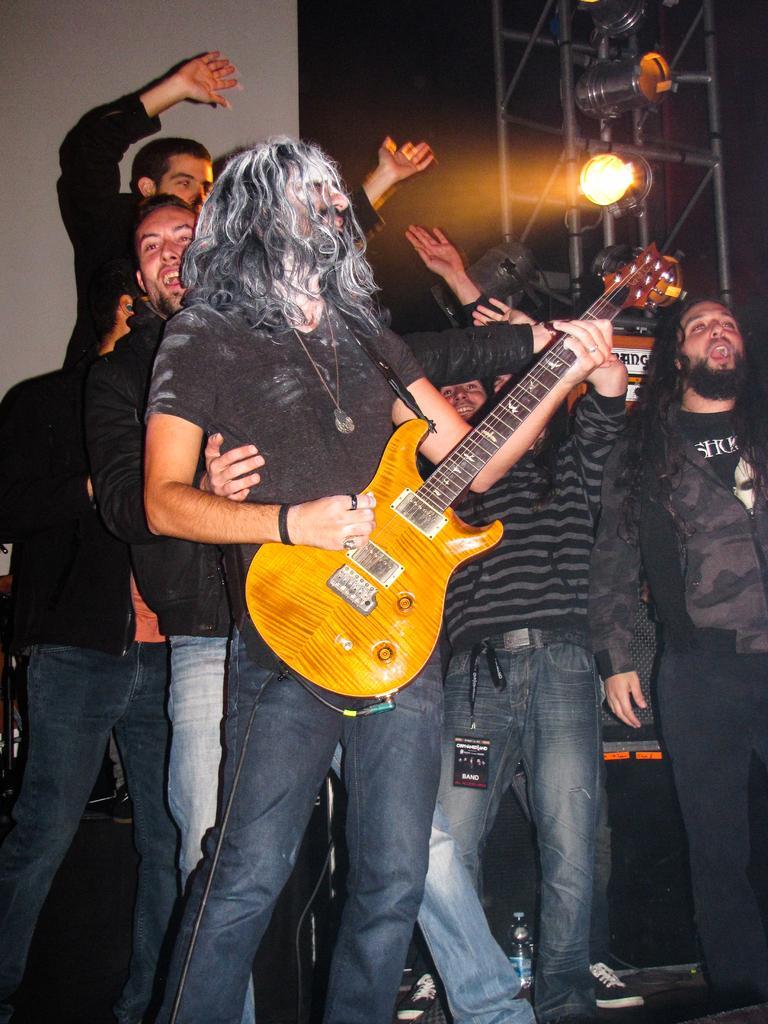Describe this image in one or two sentences. In this image, There are some people standing and a person holding a music instrument which is in yellow color, In the background there is a table on that table there is a light and there a wall of white color. 